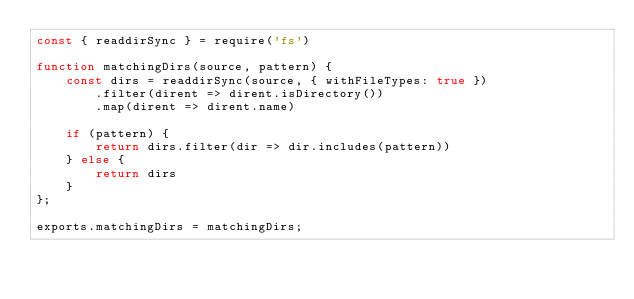Convert code to text. <code><loc_0><loc_0><loc_500><loc_500><_JavaScript_>const { readdirSync } = require('fs')

function matchingDirs(source, pattern) {
    const dirs = readdirSync(source, { withFileTypes: true })
        .filter(dirent => dirent.isDirectory())
        .map(dirent => dirent.name)

    if (pattern) {
        return dirs.filter(dir => dir.includes(pattern))
    } else {
        return dirs
    }
};

exports.matchingDirs = matchingDirs;
</code> 